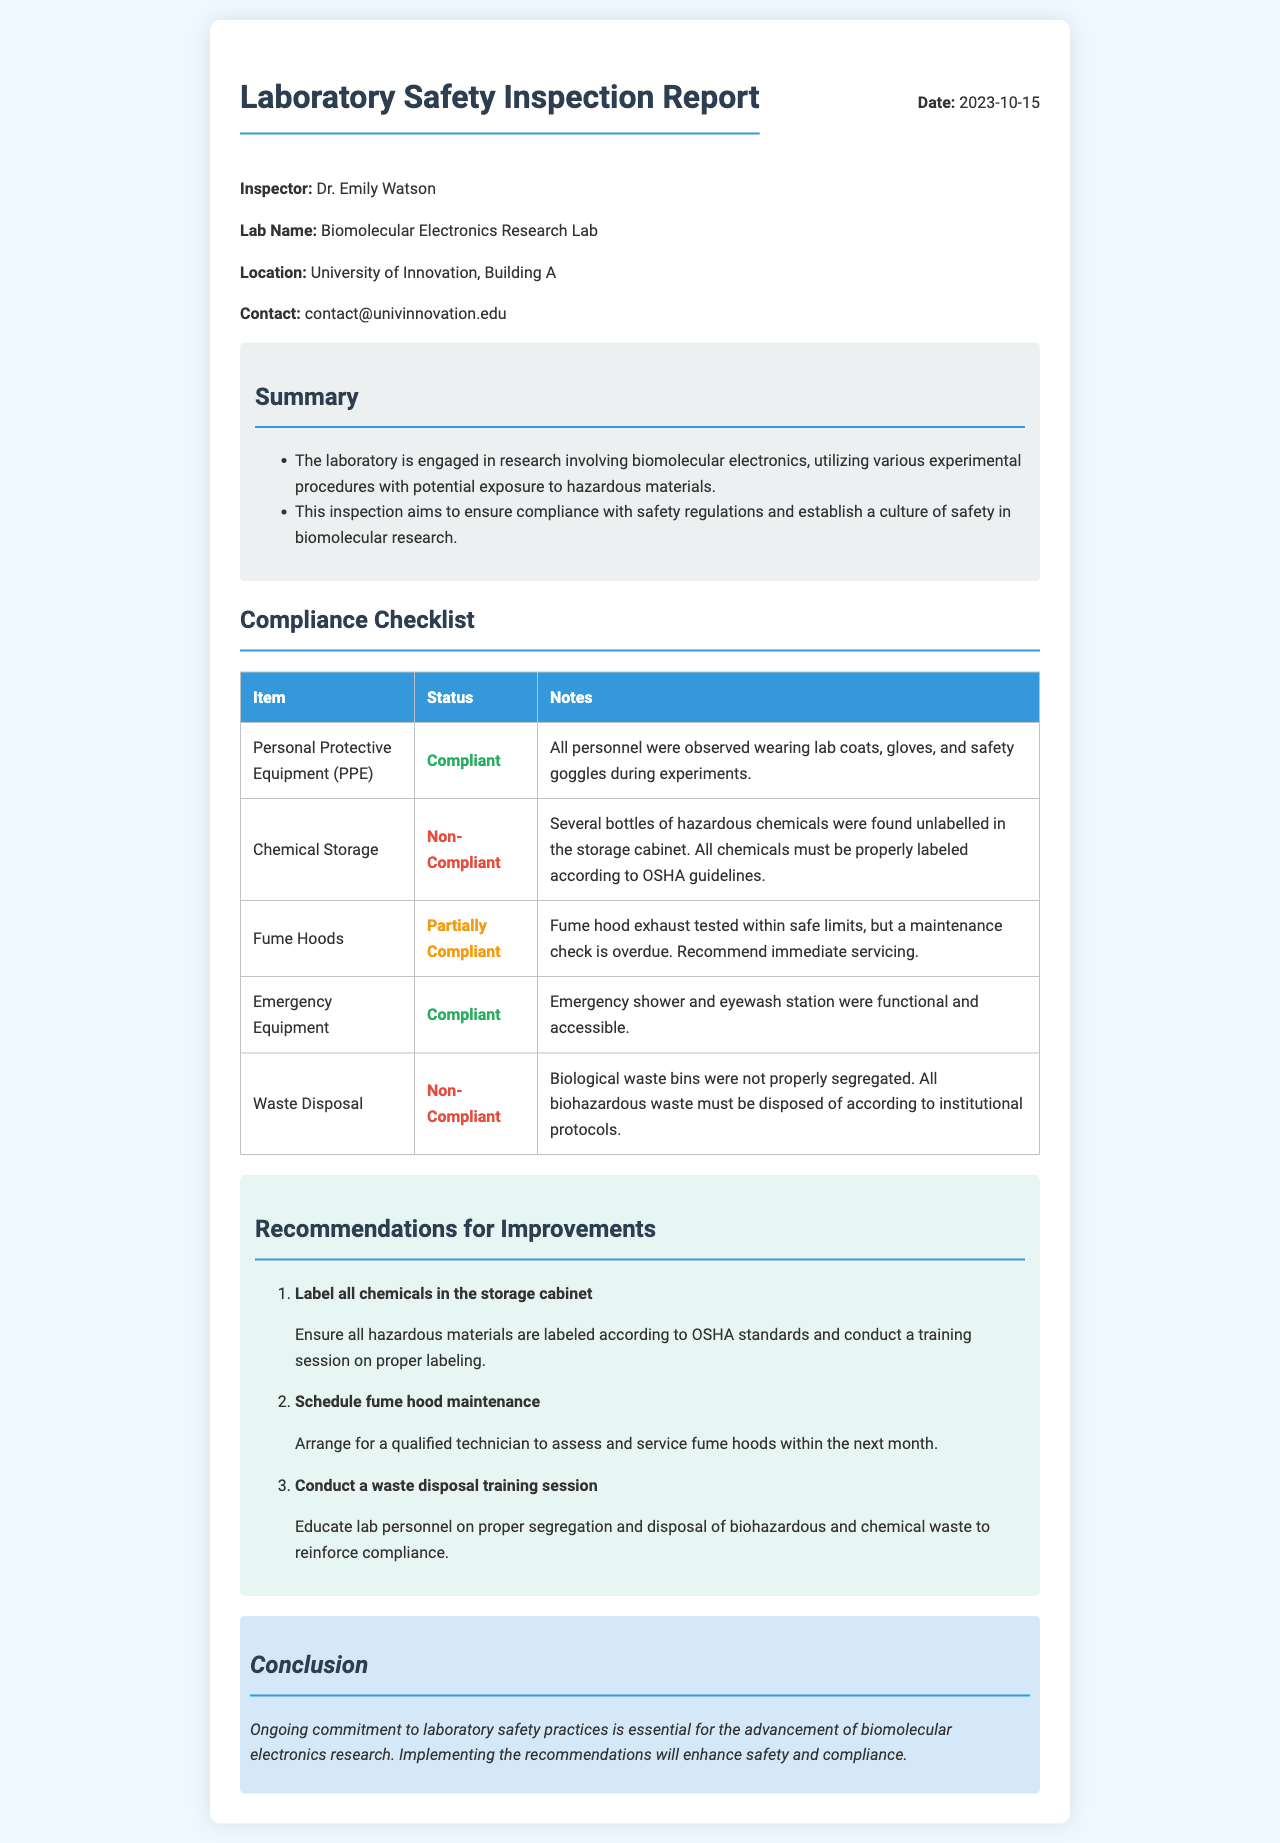what is the date of the inspection? The date of the inspection is explicitly stated in the document under the header section.
Answer: 2023-10-15 who is the inspector? The inspector's name is mentioned prominently at the beginning of the report.
Answer: Dr. Emily Watson what is the name of the laboratory? The laboratory name is listed in the report as part of the introductory information.
Answer: Biomolecular Electronics Research Lab how many non-compliant items are listed in the compliance checklist? The compliance checklist summarizes the items and their statuses, allowing for counting the non-compliant entries.
Answer: 2 what is one recommendation for improvement regarding waste disposal? The recommendations section provides specific actions to address compliance issues, particularly waste disposal.
Answer: Conduct a waste disposal training session are all personnel wearing PPE during experiments? The status of PPE compliance is noted in the checklist, indicating whether it was adhered to.
Answer: Compliant what maintenance action is recommended for the fume hoods? The recommendations suggest specific actions related to the fume hoods based on the inspection findings.
Answer: Schedule fume hood maintenance what are the two compliant items listed in the compliance checklist? The compliant items can be found in the table with their respective statuses, requiring identification of items that meet compliance standards.
Answer: Personal Protective Equipment, Emergency Equipment 